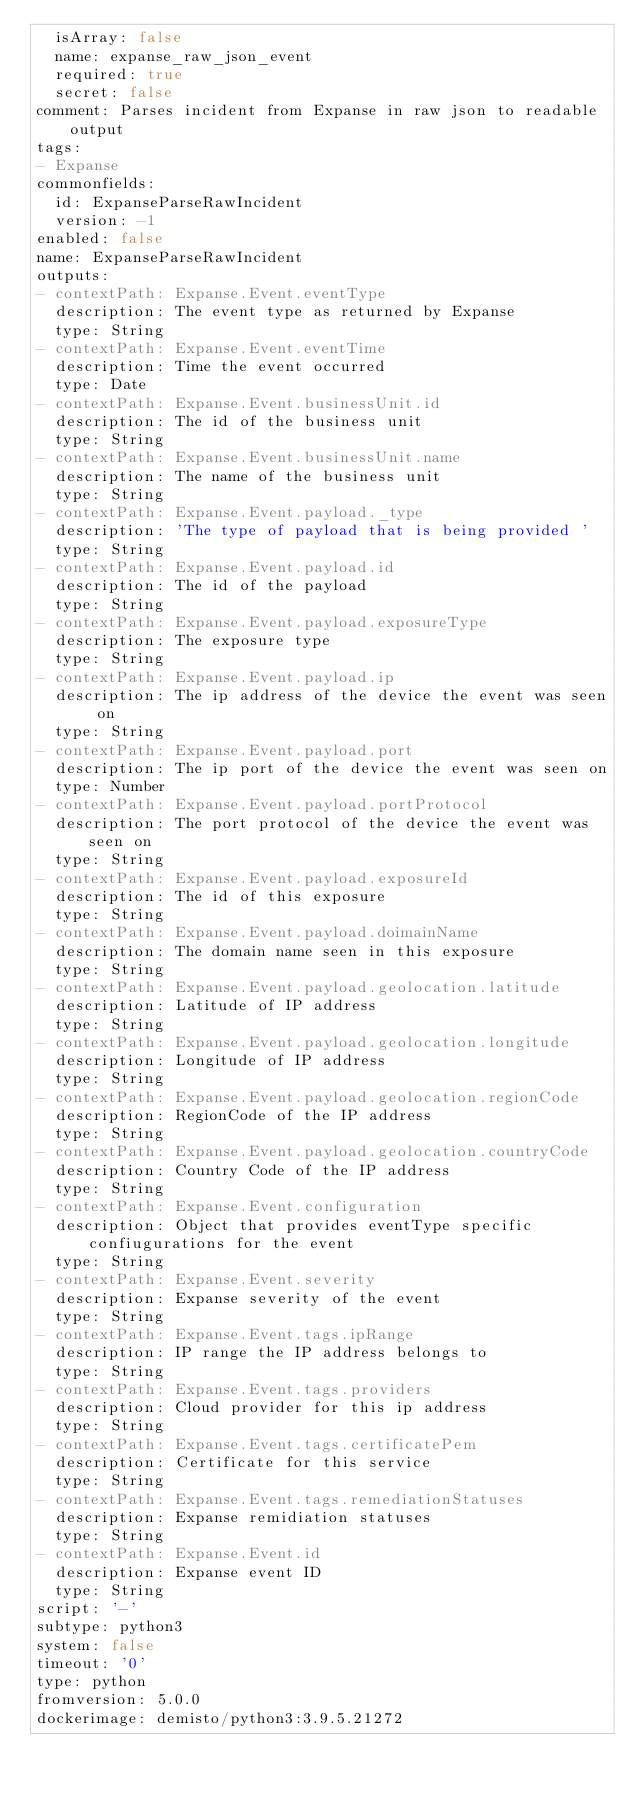<code> <loc_0><loc_0><loc_500><loc_500><_YAML_>  isArray: false
  name: expanse_raw_json_event
  required: true
  secret: false
comment: Parses incident from Expanse in raw json to readable output
tags:
- Expanse
commonfields:
  id: ExpanseParseRawIncident
  version: -1
enabled: false
name: ExpanseParseRawIncident
outputs:
- contextPath: Expanse.Event.eventType
  description: The event type as returned by Expanse
  type: String
- contextPath: Expanse.Event.eventTime
  description: Time the event occurred
  type: Date
- contextPath: Expanse.Event.businessUnit.id
  description: The id of the business unit
  type: String
- contextPath: Expanse.Event.businessUnit.name
  description: The name of the business unit
  type: String
- contextPath: Expanse.Event.payload._type
  description: 'The type of payload that is being provided '
  type: String
- contextPath: Expanse.Event.payload.id
  description: The id of the payload
  type: String
- contextPath: Expanse.Event.payload.exposureType
  description: The exposure type
  type: String
- contextPath: Expanse.Event.payload.ip
  description: The ip address of the device the event was seen on
  type: String
- contextPath: Expanse.Event.payload.port
  description: The ip port of the device the event was seen on
  type: Number
- contextPath: Expanse.Event.payload.portProtocol
  description: The port protocol of the device the event was seen on
  type: String
- contextPath: Expanse.Event.payload.exposureId
  description: The id of this exposure
  type: String
- contextPath: Expanse.Event.payload.doimainName
  description: The domain name seen in this exposure
  type: String
- contextPath: Expanse.Event.payload.geolocation.latitude
  description: Latitude of IP address
  type: String
- contextPath: Expanse.Event.payload.geolocation.longitude
  description: Longitude of IP address
  type: String
- contextPath: Expanse.Event.payload.geolocation.regionCode
  description: RegionCode of the IP address
  type: String
- contextPath: Expanse.Event.payload.geolocation.countryCode
  description: Country Code of the IP address
  type: String
- contextPath: Expanse.Event.configuration
  description: Object that provides eventType specific confiugurations for the event
  type: String
- contextPath: Expanse.Event.severity
  description: Expanse severity of the event
  type: String
- contextPath: Expanse.Event.tags.ipRange
  description: IP range the IP address belongs to
  type: String
- contextPath: Expanse.Event.tags.providers
  description: Cloud provider for this ip address
  type: String
- contextPath: Expanse.Event.tags.certificatePem
  description: Certificate for this service
  type: String
- contextPath: Expanse.Event.tags.remediationStatuses
  description: Expanse remidiation statuses
  type: String
- contextPath: Expanse.Event.id
  description: Expanse event ID
  type: String
script: '-'
subtype: python3
system: false
timeout: '0'
type: python
fromversion: 5.0.0
dockerimage: demisto/python3:3.9.5.21272
</code> 